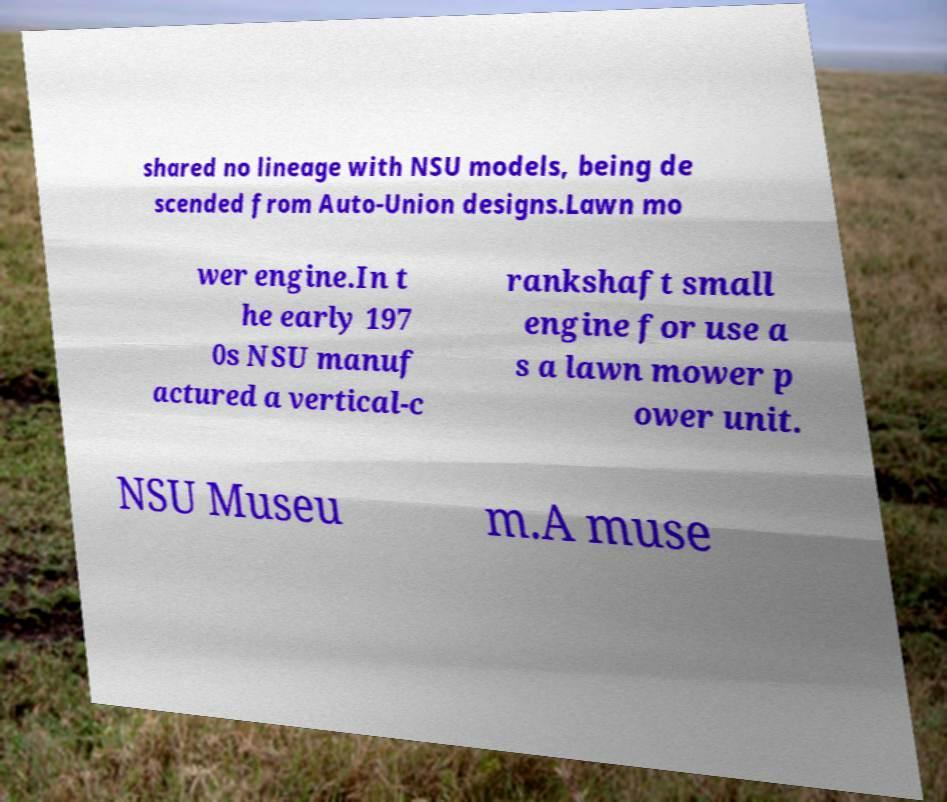Please read and relay the text visible in this image. What does it say? shared no lineage with NSU models, being de scended from Auto-Union designs.Lawn mo wer engine.In t he early 197 0s NSU manuf actured a vertical-c rankshaft small engine for use a s a lawn mower p ower unit. NSU Museu m.A muse 